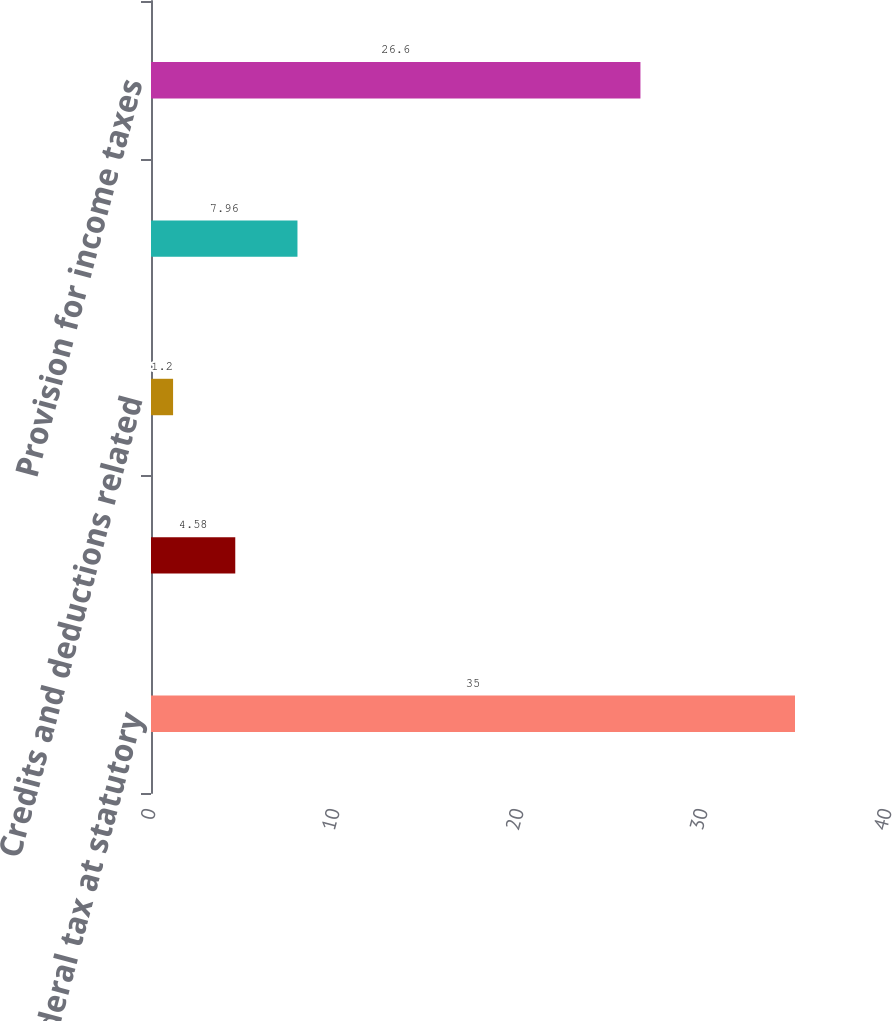<chart> <loc_0><loc_0><loc_500><loc_500><bar_chart><fcel>US federal tax at statutory<fcel>State and local taxes - net of<fcel>Credits and deductions related<fcel>Foreign rate differential<fcel>Provision for income taxes<nl><fcel>35<fcel>4.58<fcel>1.2<fcel>7.96<fcel>26.6<nl></chart> 